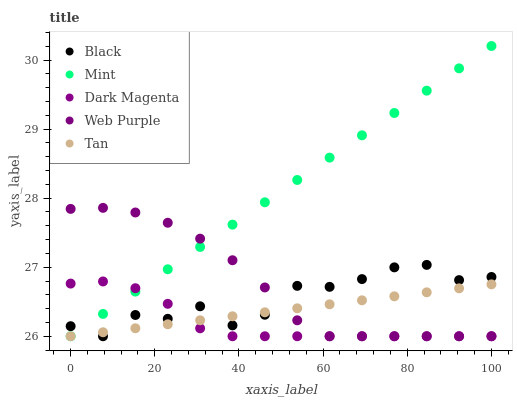Does Dark Magenta have the minimum area under the curve?
Answer yes or no. Yes. Does Mint have the maximum area under the curve?
Answer yes or no. Yes. Does Web Purple have the minimum area under the curve?
Answer yes or no. No. Does Web Purple have the maximum area under the curve?
Answer yes or no. No. Is Tan the smoothest?
Answer yes or no. Yes. Is Black the roughest?
Answer yes or no. Yes. Is Mint the smoothest?
Answer yes or no. No. Is Mint the roughest?
Answer yes or no. No. Does Tan have the lowest value?
Answer yes or no. Yes. Does Mint have the highest value?
Answer yes or no. Yes. Does Web Purple have the highest value?
Answer yes or no. No. Does Web Purple intersect Tan?
Answer yes or no. Yes. Is Web Purple less than Tan?
Answer yes or no. No. Is Web Purple greater than Tan?
Answer yes or no. No. 